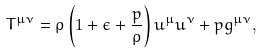Convert formula to latex. <formula><loc_0><loc_0><loc_500><loc_500>T ^ { \mu \nu } = \rho \left ( 1 + \epsilon + \frac { p } { \rho } \right ) u ^ { \mu } u ^ { \nu } + p g ^ { \mu \nu } ,</formula> 